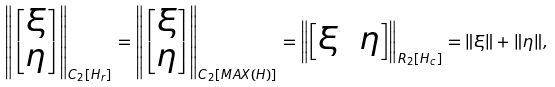<formula> <loc_0><loc_0><loc_500><loc_500>\left \| \begin{bmatrix} \xi \\ \eta \end{bmatrix} \right \| _ { C _ { 2 } [ H _ { r } ] } = \left \| \begin{bmatrix} \xi \\ \eta \end{bmatrix} \right \| _ { C _ { 2 } [ M A X ( H ) ] } = \left \| \begin{bmatrix} \xi \, & \eta \end{bmatrix} \right \| _ { R _ { 2 } [ H _ { c } ] } = \| \xi \| + \| \eta \| ,</formula> 